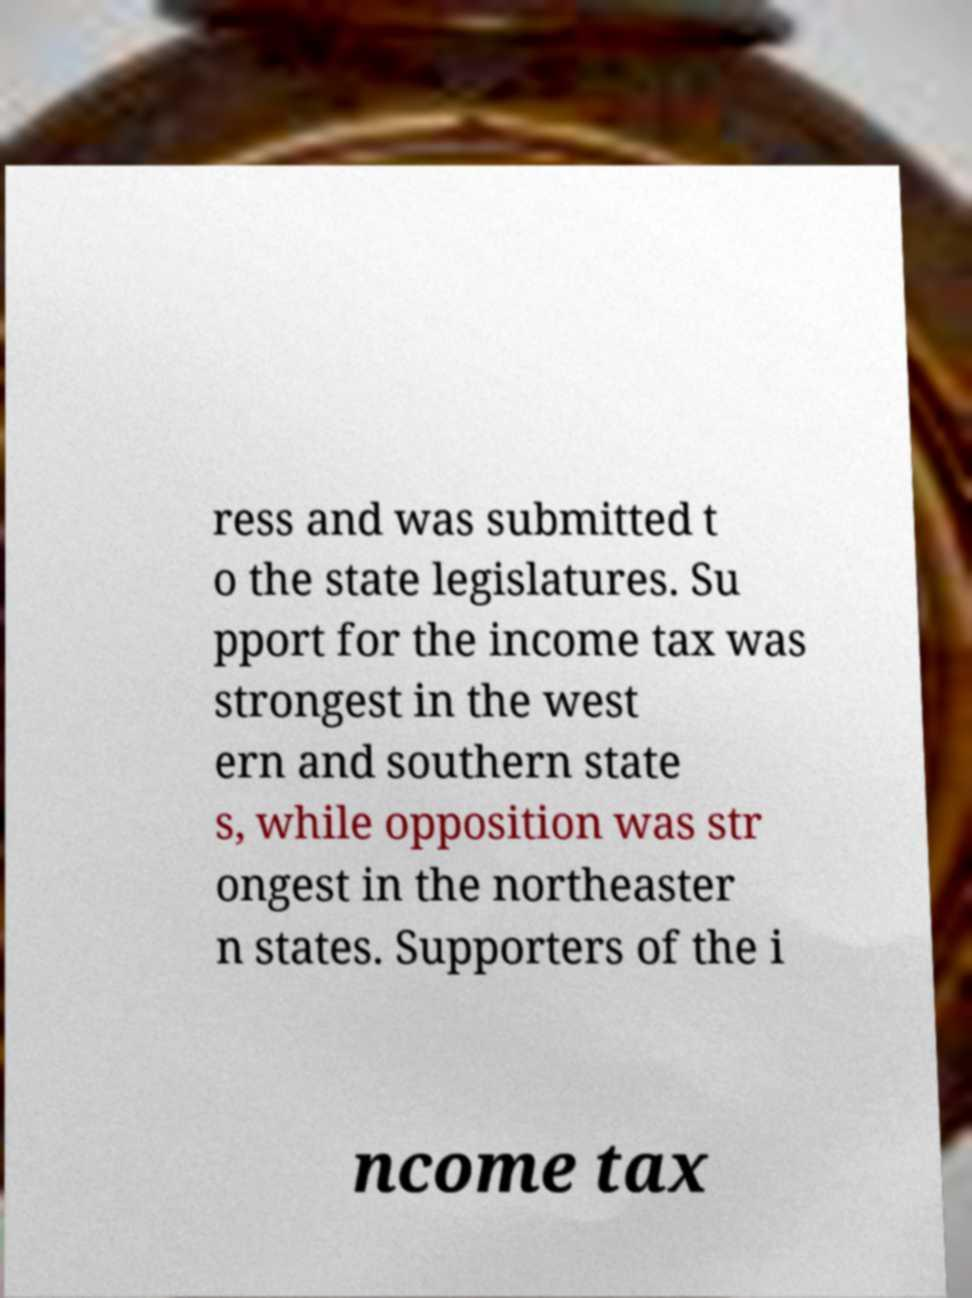Could you assist in decoding the text presented in this image and type it out clearly? ress and was submitted t o the state legislatures. Su pport for the income tax was strongest in the west ern and southern state s, while opposition was str ongest in the northeaster n states. Supporters of the i ncome tax 